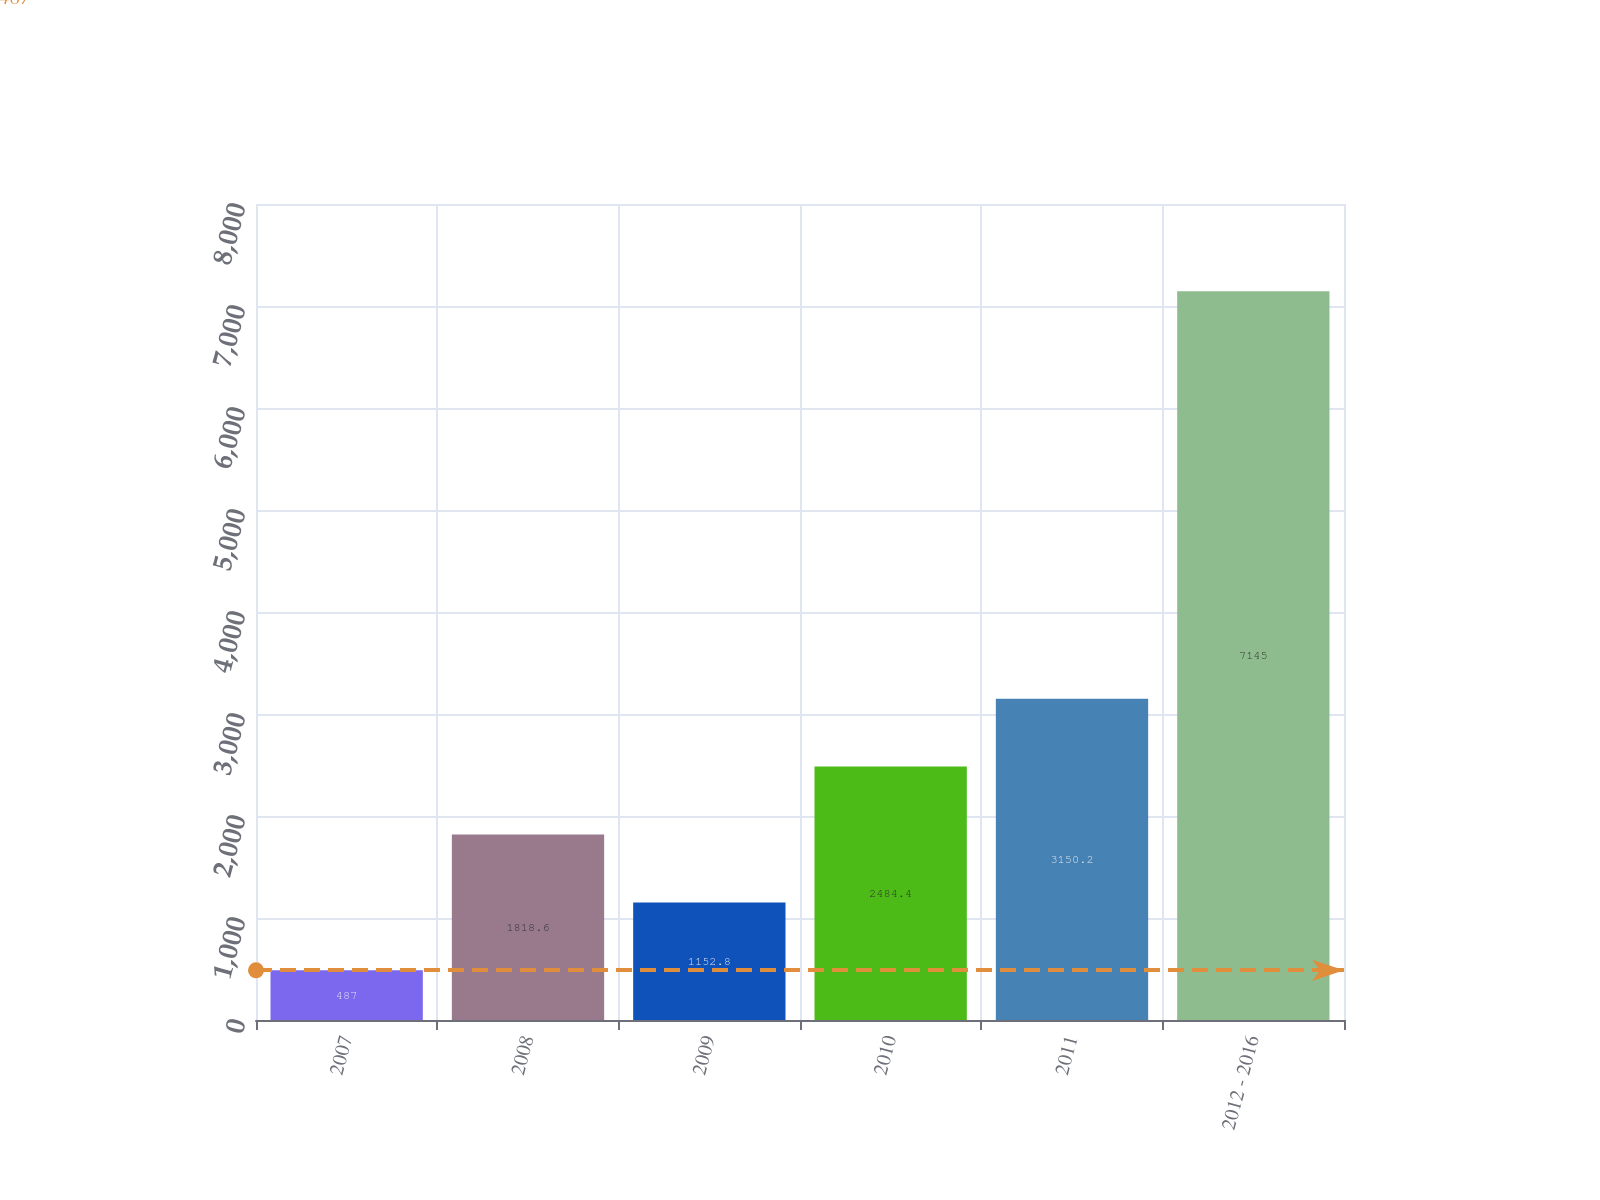Convert chart to OTSL. <chart><loc_0><loc_0><loc_500><loc_500><bar_chart><fcel>2007<fcel>2008<fcel>2009<fcel>2010<fcel>2011<fcel>2012 - 2016<nl><fcel>487<fcel>1818.6<fcel>1152.8<fcel>2484.4<fcel>3150.2<fcel>7145<nl></chart> 